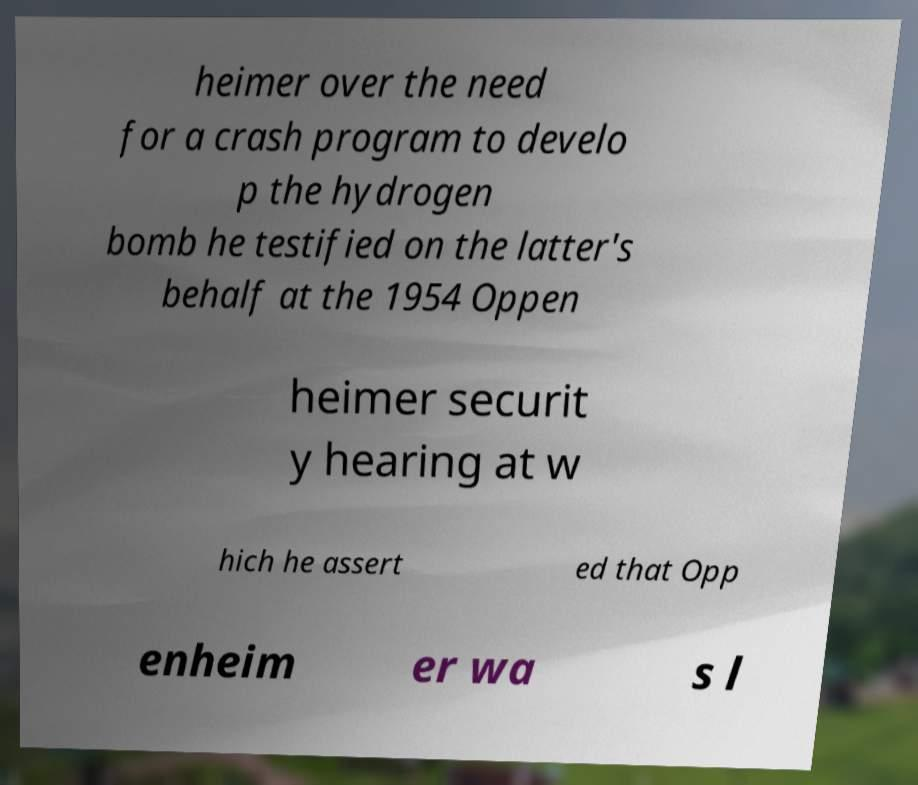I need the written content from this picture converted into text. Can you do that? heimer over the need for a crash program to develo p the hydrogen bomb he testified on the latter's behalf at the 1954 Oppen heimer securit y hearing at w hich he assert ed that Opp enheim er wa s l 